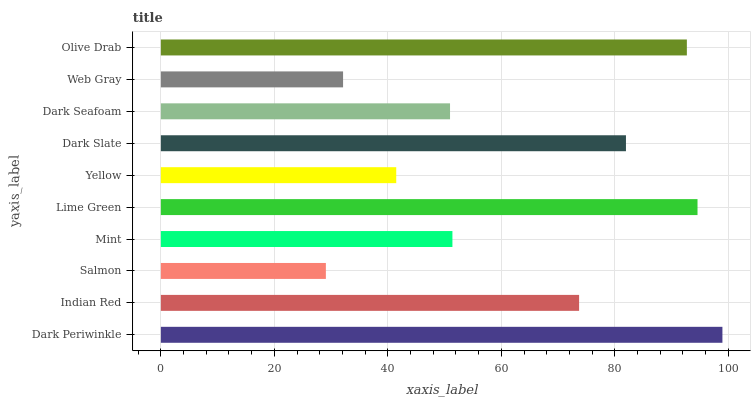Is Salmon the minimum?
Answer yes or no. Yes. Is Dark Periwinkle the maximum?
Answer yes or no. Yes. Is Indian Red the minimum?
Answer yes or no. No. Is Indian Red the maximum?
Answer yes or no. No. Is Dark Periwinkle greater than Indian Red?
Answer yes or no. Yes. Is Indian Red less than Dark Periwinkle?
Answer yes or no. Yes. Is Indian Red greater than Dark Periwinkle?
Answer yes or no. No. Is Dark Periwinkle less than Indian Red?
Answer yes or no. No. Is Indian Red the high median?
Answer yes or no. Yes. Is Mint the low median?
Answer yes or no. Yes. Is Olive Drab the high median?
Answer yes or no. No. Is Indian Red the low median?
Answer yes or no. No. 